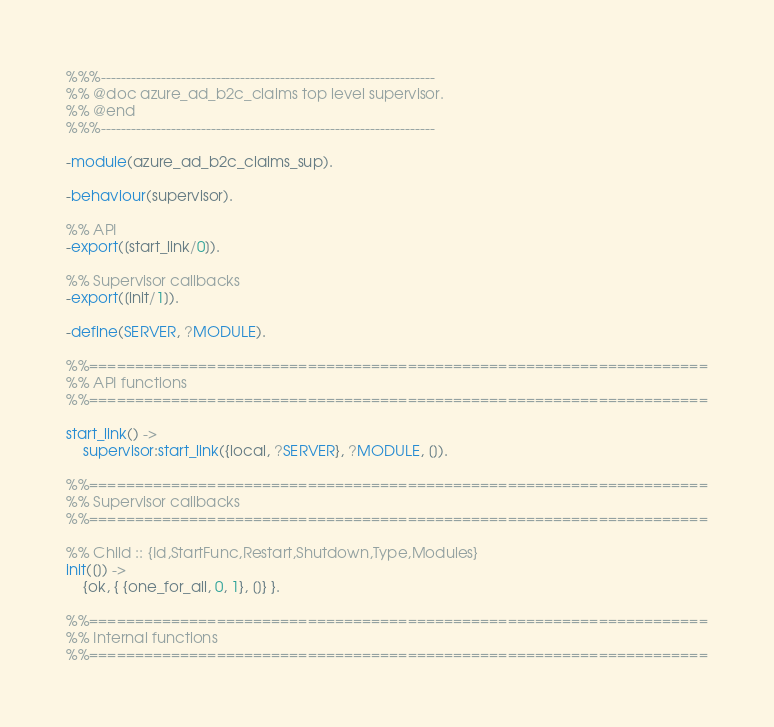Convert code to text. <code><loc_0><loc_0><loc_500><loc_500><_Erlang_>%%%-------------------------------------------------------------------
%% @doc azure_ad_b2c_claims top level supervisor.
%% @end
%%%-------------------------------------------------------------------

-module(azure_ad_b2c_claims_sup).

-behaviour(supervisor).

%% API
-export([start_link/0]).

%% Supervisor callbacks
-export([init/1]).

-define(SERVER, ?MODULE).

%%====================================================================
%% API functions
%%====================================================================

start_link() ->
    supervisor:start_link({local, ?SERVER}, ?MODULE, []).

%%====================================================================
%% Supervisor callbacks
%%====================================================================

%% Child :: {Id,StartFunc,Restart,Shutdown,Type,Modules}
init([]) ->
    {ok, { {one_for_all, 0, 1}, []} }.

%%====================================================================
%% Internal functions
%%====================================================================
</code> 